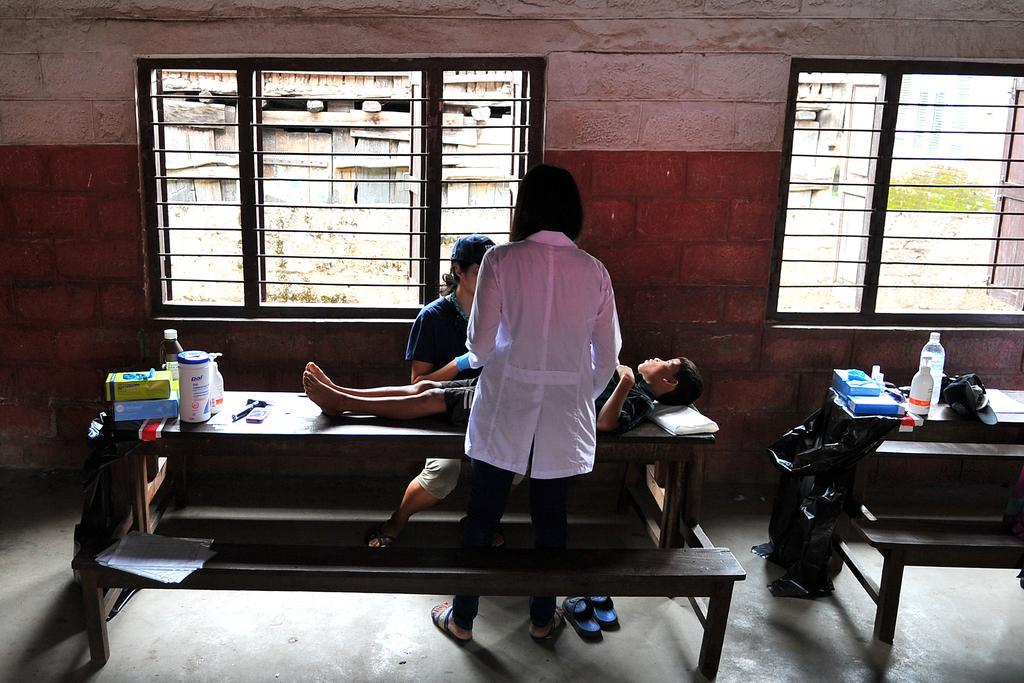Please provide a concise description of this image. In this image, there are a few people. Among them, we can see a person is standing and a person is sitting. We can also see a person lying. We can see some benches with objects like bottles. We can see the ground and the wall with some windows. We can also see some green colored objects. 